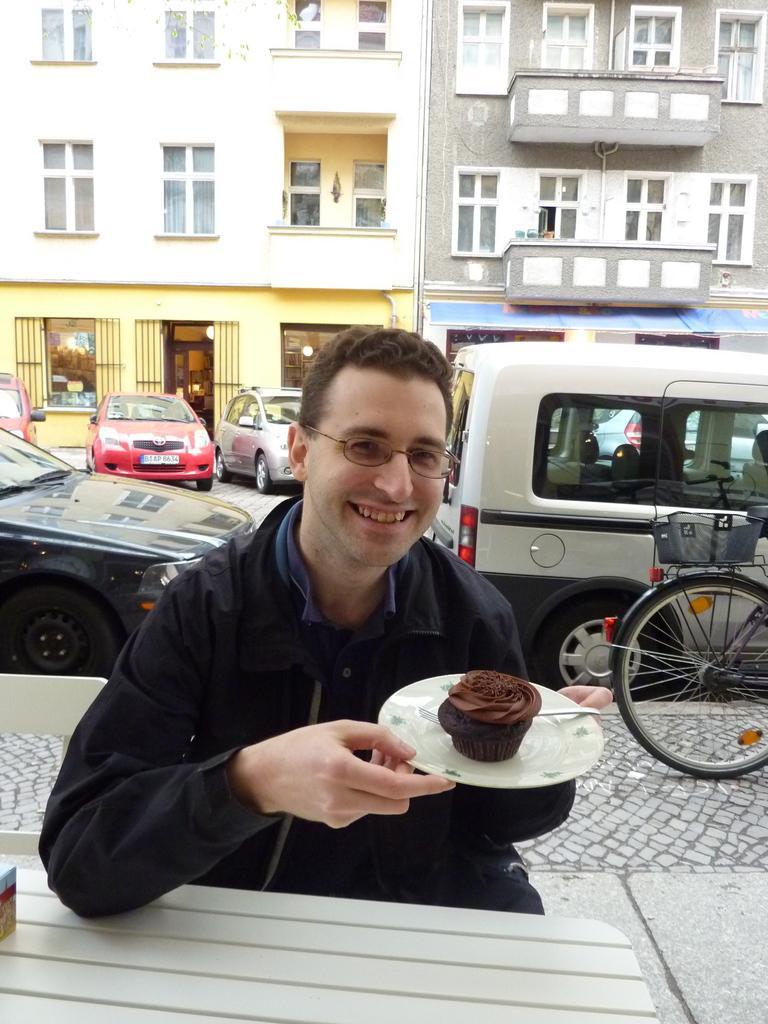Please provide a concise description of this image. In this picture we can see a man sitting and holding a plate. In the plate there is food and a spoon. In front of the man, there is an object on the table. Behind the man, there are vehicles and a bicycle and there are buildings with windows and doors. 